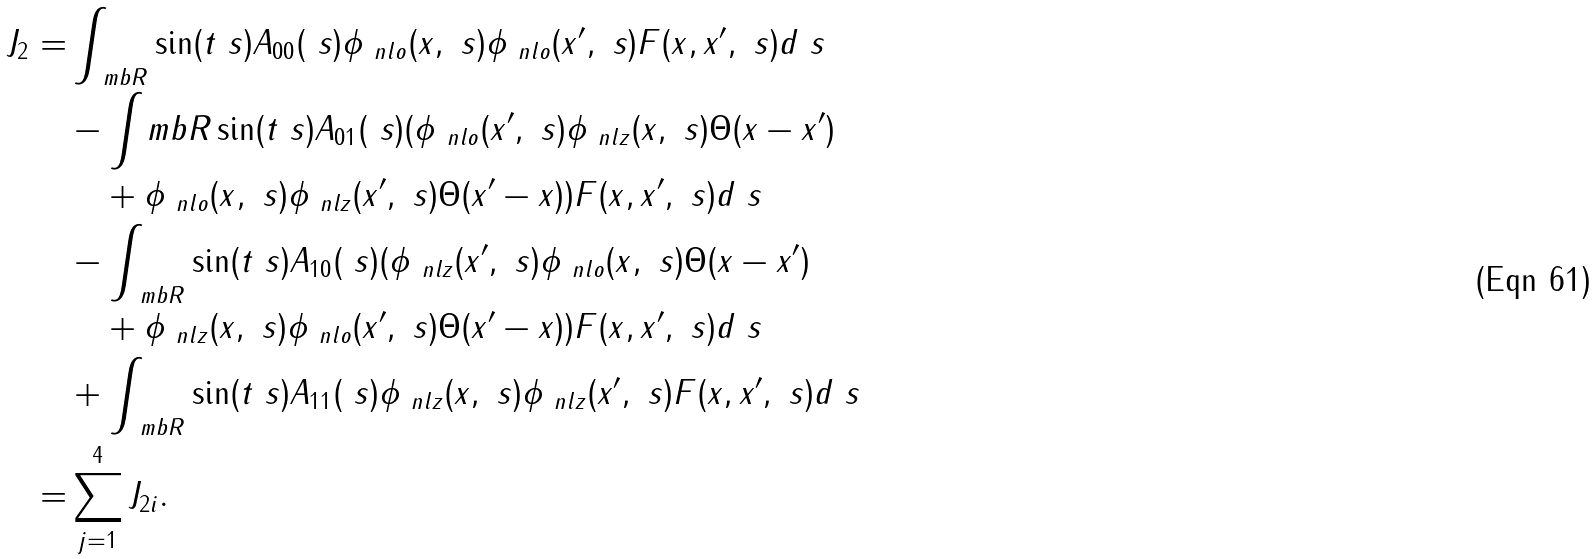Convert formula to latex. <formula><loc_0><loc_0><loc_500><loc_500>J _ { 2 } = & \int _ { \ m b R } \sin ( t \ s ) A _ { 0 0 } ( \ s ) \phi _ { \ n l o } ( x , \ s ) \phi _ { \ n l o } ( x ^ { \prime } , \ s ) F ( x , x ^ { \prime } , \ s ) d \ s \\ & - \int _ { \ } m b R \sin ( t \ s ) A _ { 0 1 } ( \ s ) ( \phi _ { \ n l o } ( x ^ { \prime } , \ s ) \phi _ { \ n l z } ( x , \ s ) \Theta ( x - x ^ { \prime } ) \\ & \quad + \phi _ { \ n l o } ( x , \ s ) \phi _ { \ n l z } ( x ^ { \prime } , \ s ) \Theta ( x ^ { \prime } - x ) ) F ( x , x ^ { \prime } , \ s ) d \ s \\ & - \int _ { \ m b R } \sin ( t \ s ) A _ { 1 0 } ( \ s ) ( \phi _ { \ n l z } ( x ^ { \prime } , \ s ) \phi _ { \ n l o } ( x , \ s ) \Theta ( x - x ^ { \prime } ) \\ & \quad + \phi _ { \ n l z } ( x , \ s ) \phi _ { \ n l o } ( x ^ { \prime } , \ s ) \Theta ( x ^ { \prime } - x ) ) F ( x , x ^ { \prime } , \ s ) d \ s \\ & + \int _ { \ m b R } \sin ( t \ s ) A _ { 1 1 } ( \ s ) \phi _ { \ n l z } ( x , \ s ) \phi _ { \ n l z } ( x ^ { \prime } , \ s ) F ( x , x ^ { \prime } , \ s ) d \ s \\ = & \sum _ { j = 1 } ^ { 4 } J _ { 2 i } .</formula> 